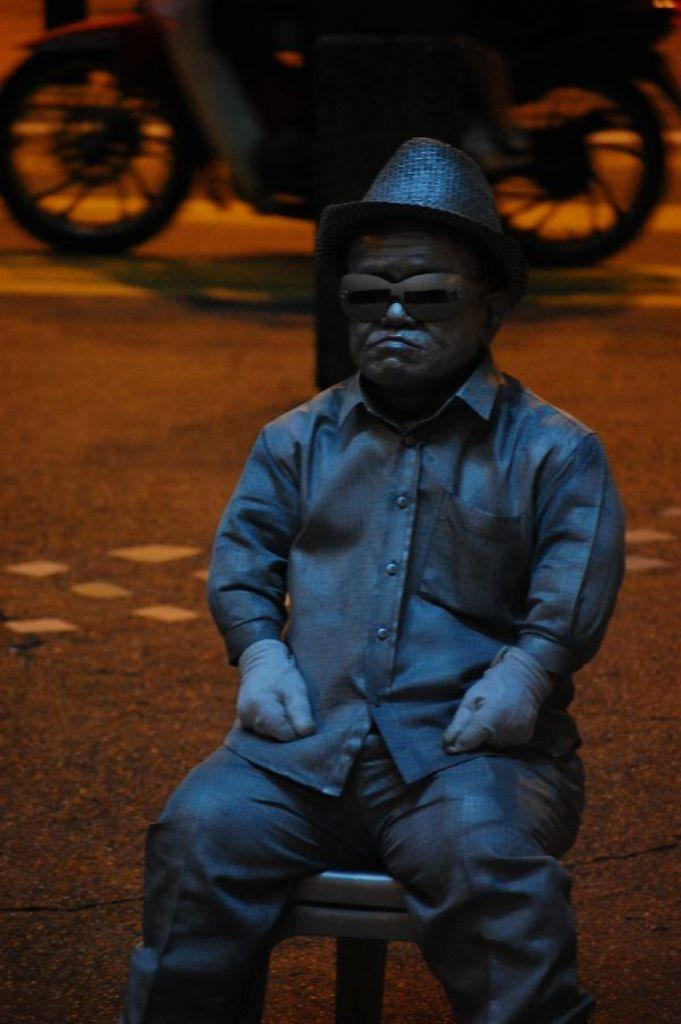What is the main subject of the image? The main subject of the image is a statue of a midget. What is the statue doing in the image? The statue is sitting on a chair in the image. What else can be seen in the image besides the statue? There is a motorcycle visible in the image. Where is the motorcycle located in the image? The motorcycle is on the road in the image. What type of bead is hanging from the mailbox in the image? There is no mailbox or bead present in the image. Is the motorcycle smoking in the image? No, the motorcycle is not smoking in the image; it is simply parked on the road. 